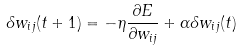Convert formula to latex. <formula><loc_0><loc_0><loc_500><loc_500>\delta w _ { i j } ( t + 1 ) = - \eta \frac { \partial E } { \partial w _ { i j } } + \alpha \delta w _ { i j } ( t )</formula> 